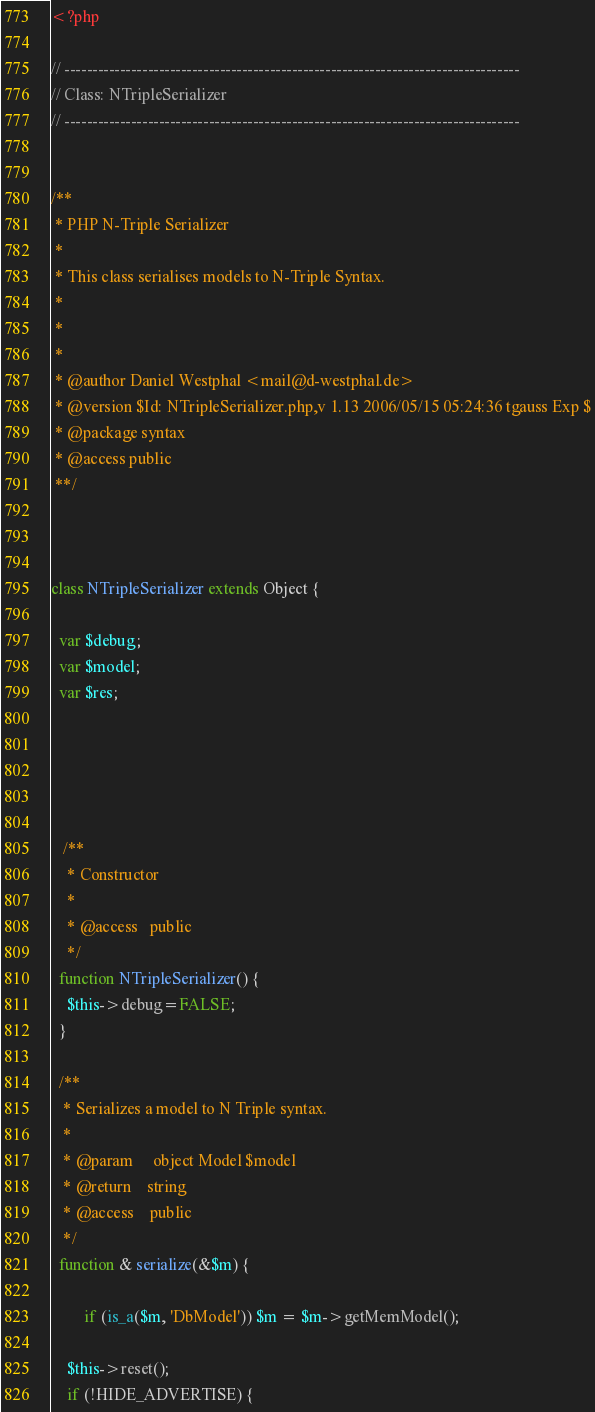<code> <loc_0><loc_0><loc_500><loc_500><_PHP_><?php

// ----------------------------------------------------------------------------------
// Class: NTripleSerializer
// ----------------------------------------------------------------------------------


/**
 * PHP N-Triple Serializer
 * 
 * This class serialises models to N-Triple Syntax.
 * 
 *
 *
 * @author Daniel Westphal <mail@d-westphal.de>
 * @version $Id: NTripleSerializer.php,v 1.13 2006/05/15 05:24:36 tgauss Exp $
 * @package syntax
 * @access public
 **/



class NTripleSerializer extends Object {

  var $debug; 
  var $model;
  var $res; 

  
  
  

   /**
    * Constructor
    *
    * @access   public
    */
  function NTripleSerializer() { 
    $this->debug=FALSE;
  }
 
  /**
   * Serializes a model to N Triple syntax.
   *
   * @param     object Model $model
   * @return    string
   * @access    public
   */
  function & serialize(&$m) { 

        if (is_a($m, 'DbModel')) $m = $m->getMemModel();
    
    $this->reset();
    if (!HIDE_ADVERTISE) {</code> 